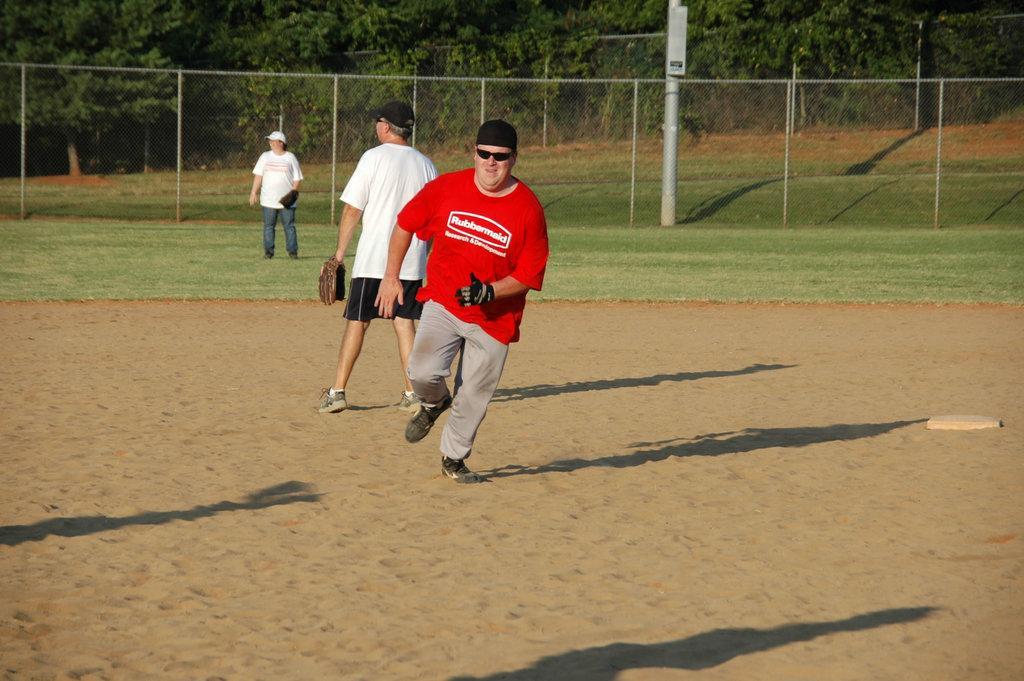In one or two sentences, can you explain what this image depicts? In this picture there is a man who is wearing red t-shirt, goggles, cap, gloves, trouser and shoes. He is running on the sand. Backside of him we can see another man who is wearing cap, t-shirt, short, gloves and shoe. Here we can see a woman who is standing on the grass. Backside of her we can see fencing. On the top we can see many trees. Here we can see a pole. 